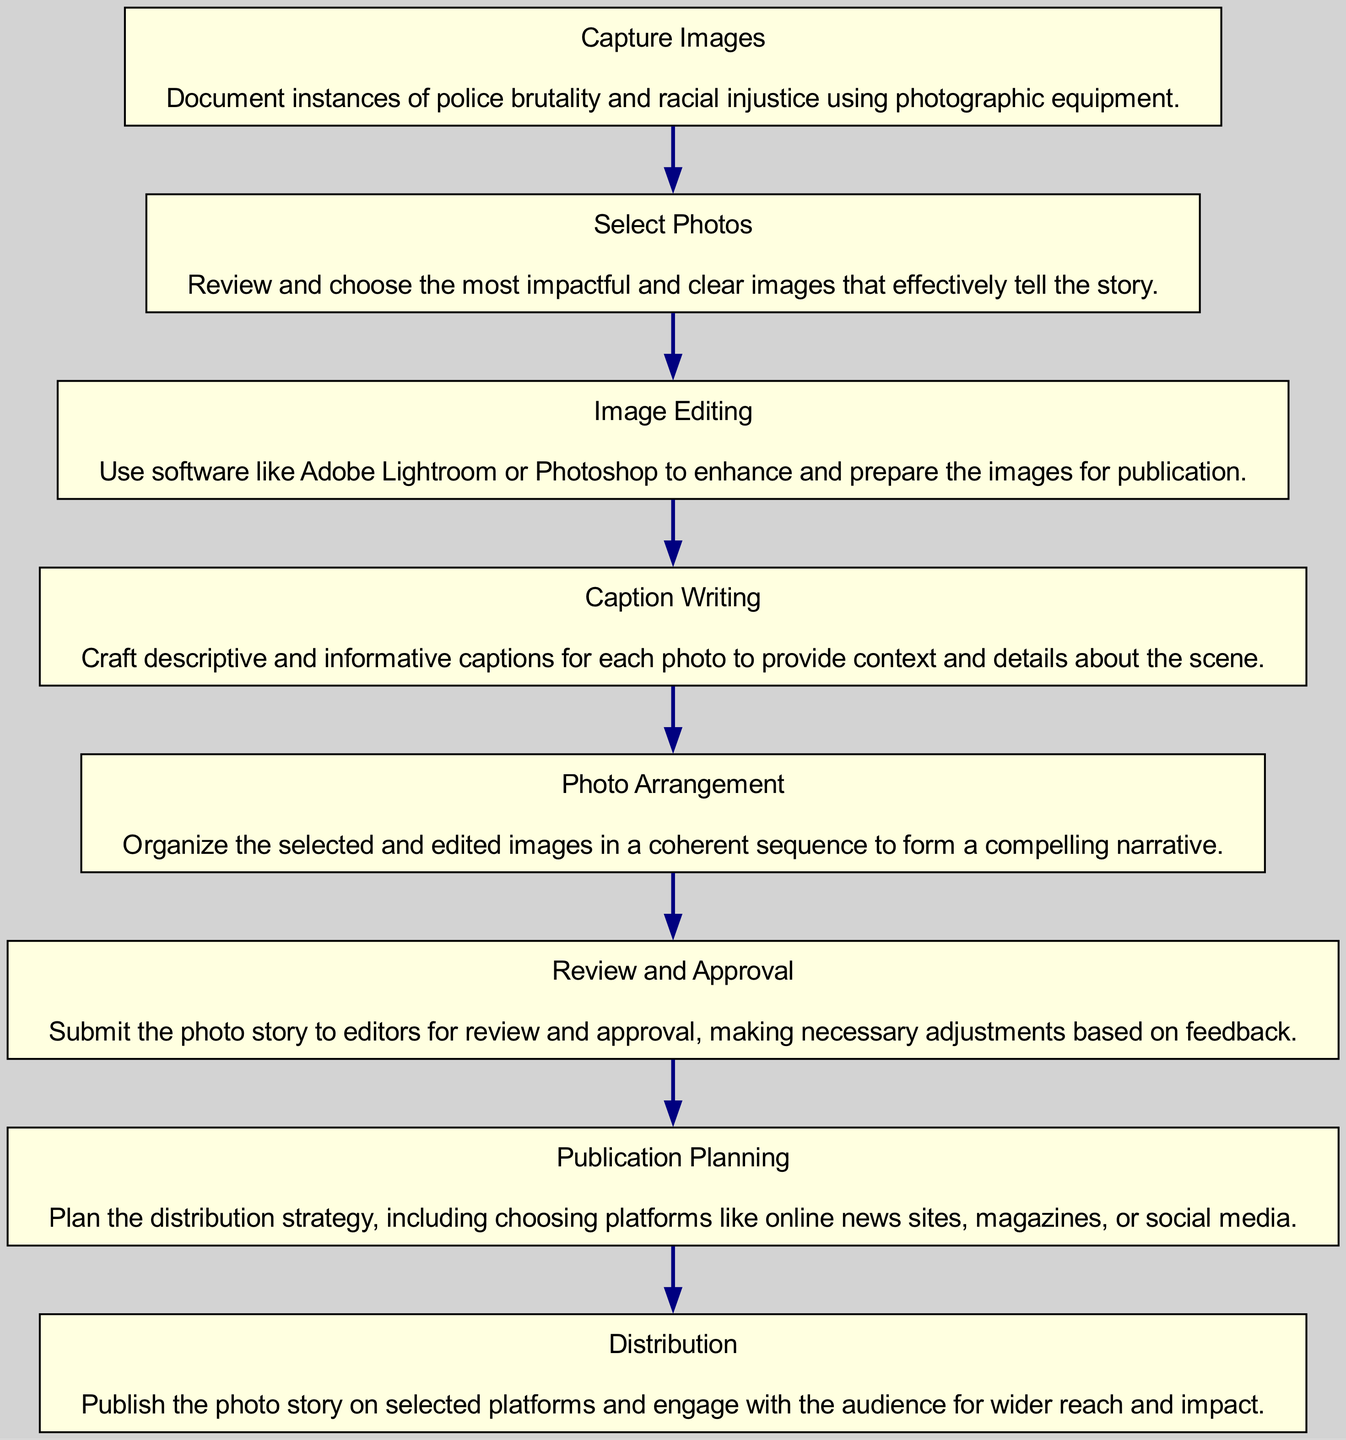What is the first step in the photo story publishing process? The first node in the diagram is "Capture Images," which indicates that documenting instances of police brutality and racial injustice is the initial action in the process.
Answer: Capture Images How many steps are there in the process? By counting each individual node in the diagram, there are a total of eight steps in the process, from "Capture Images" to "Distribution."
Answer: Eight What comes after "Image Editing"? The flow from the "Image Editing" node leads directly to the next node, which is "Caption Writing", indicating it is the next step to occur in the sequence.
Answer: Caption Writing What is the last step before "Distribution"? The node immediately preceding "Distribution" in the flow is "Publication Planning." Therefore, it is the final step before the distribution of the photo story.
Answer: Publication Planning How does one proceed after "Review and Approval"? Following "Review and Approval," the process moves to "Publication Planning," indicating that this step is dependent on receiving approval from the editors.
Answer: Publication Planning What is the purpose of "Caption Writing"? The node "Caption Writing" describes crafting descriptive and informative captions for each photo, providing context and details about the scene, illustrating its importance in the storytelling process.
Answer: Provide context Which node has the description about enhancing images? The description about enhancing and preparing images for publication is located in the node labeled "Image Editing," which specifically focuses on the use of software for photo enhancement.
Answer: Image Editing What is the relationship between "Select Photos" and "Image Editing"? "Select Photos" leads directly into "Image Editing," indicating that once impactful photos are chosen during the "Select Photos" step, they proceed to the editing phase for enhancement.
Answer: Sequential What are the platforms mentioned in "Publication Planning"? While the specific platforms are not detailed in the node, it states that the planning includes choosing distribution platforms like online news sites, magazines, or social media.
Answer: Online news sites, magazines, or social media 